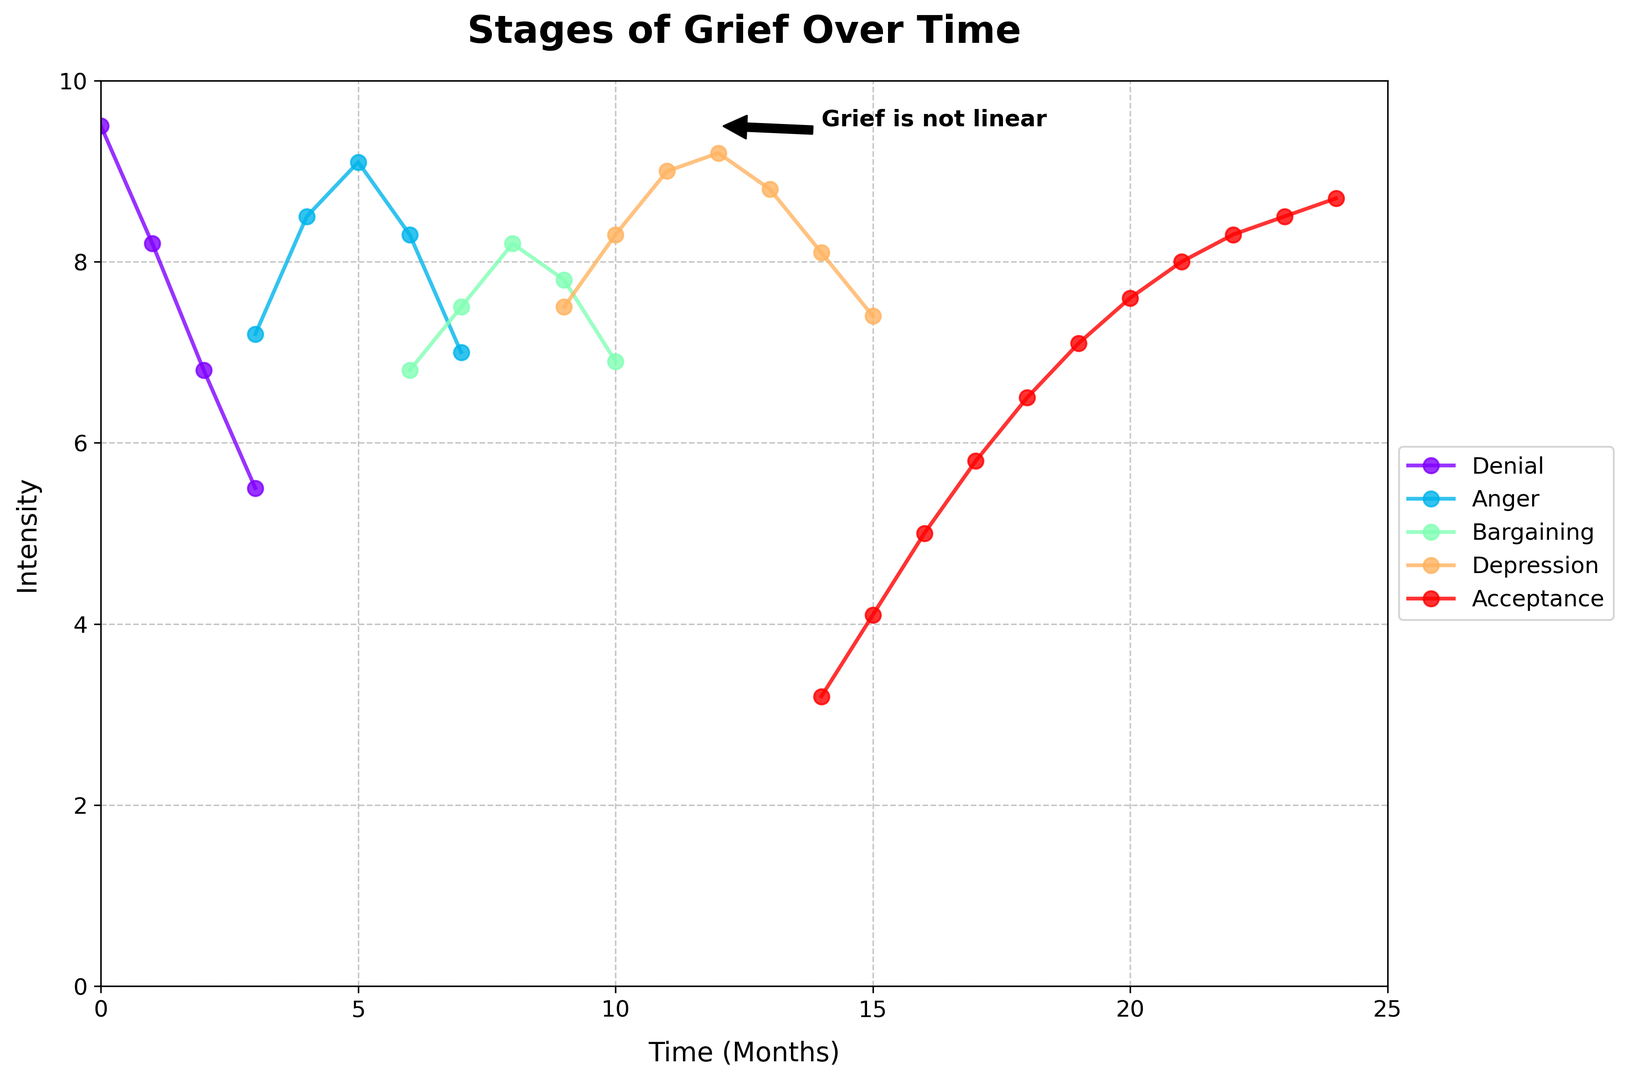What's the highest intensity level reached during the Depression stage? To determine the highest intensity during the Depression stage, locate the line corresponding to Depression and find the maximum value on the y-axis (Intensity). The peak of the Depression curve reaches 9.2.
Answer: 9.2 Which grief stage has the lowest initial intensity? The initial intensity is assessed at the earliest time point for each stage. For Denial, it is 9.5; for Anger, it's 7.2; for Bargaining, it's 6.8; for Depression, it's 7.5; for Acceptance, it's 3.2. Comparing these values, Acceptance has the lowest initial intensity.
Answer: Acceptance How does the intensity of Anger change from 3 to 6 months? Identify the line for Anger and observe the Intensity values for months 3, 4, 5, and 6. These values are 7.2, 8.5, 9.1, and 8.3, respectively. The Intensity first increases and then starts to decrease by the 6th month.
Answer: Increases then decreases What is the average intensity of the Acceptance stage from month 17 to month 21? The Acceptance stage values for months 17 to 21 are 5.8, 6.5, 7.1, 7.6, and 8.0. Calculate the sum (5.8+6.5+7.1+7.6+8.0=35) and divide by the number of data points (5). The average is 35/5.
Answer: 7.0 How many months does it take for the Denial stage to drop below an intensity of 6? Check the Intensity values for the Denial stage. They are 9.5, 8.2, 6.8, 5.5 for months 0, 1, 2, and 3, respectively. The Intensity drops below 6 at month 3.
Answer: 3 months In which grief stage do we observe the biggest rise in Intensity within a single month? Compare the changes in Intensity between consecutive months for each stage: 
- Denial does not show significant rises
- Anger (between months 3 and 4: 8.5 - 7.2 = 1.3)
- Bargaining (between months 6 and 7: 7.5 - 6.8 = 0.7)
- Depression (between months 11 and 12: 9.2 - 9.0 = 0.2)
- Acceptance does not show significant rises
The largest rise occurs in the Anger stage with a change of 1.3.
Answer: Anger What is the pattern of intensity in the Bargaining stage over time? Examine the Bargaining stage's line, which shows intensity values of 6.8, 7.5, 8.2, 7.8, and 6.9 from months 6 to 10. The intensity first increases, peaks, and then decreases.
Answer: Increases, peaks, then decreases During which stages do we see an overlap in time? Look at the x-axis values where stages overlap. Denial overlaps with Anger at month 3. Anger and Bargaining overlap at month 6. Bargaining overlaps with Depression at month 9. Depression overlaps with Acceptance at month 14.
Answer: Denial-Anger, Anger-Bargaining, Bargaining-Depression, Depression-Acceptance At which month does the Acceptance stage reach an intensity of 8? Locate Acceptance's line and identify when the y-axis (Intensity) value is 8. This occurs at month 21.
Answer: Month 21 